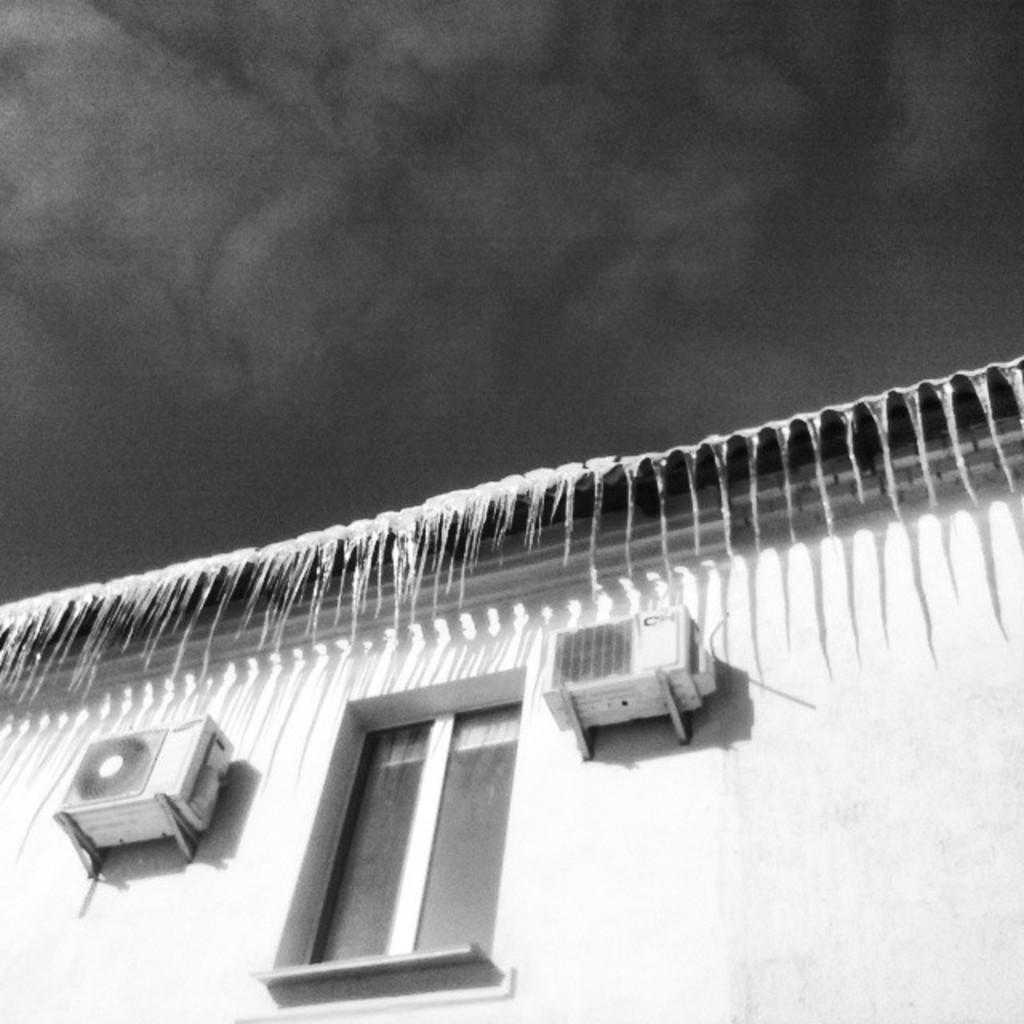How would you summarize this image in a sentence or two? This is a black and white image. There is a building which has a window. 